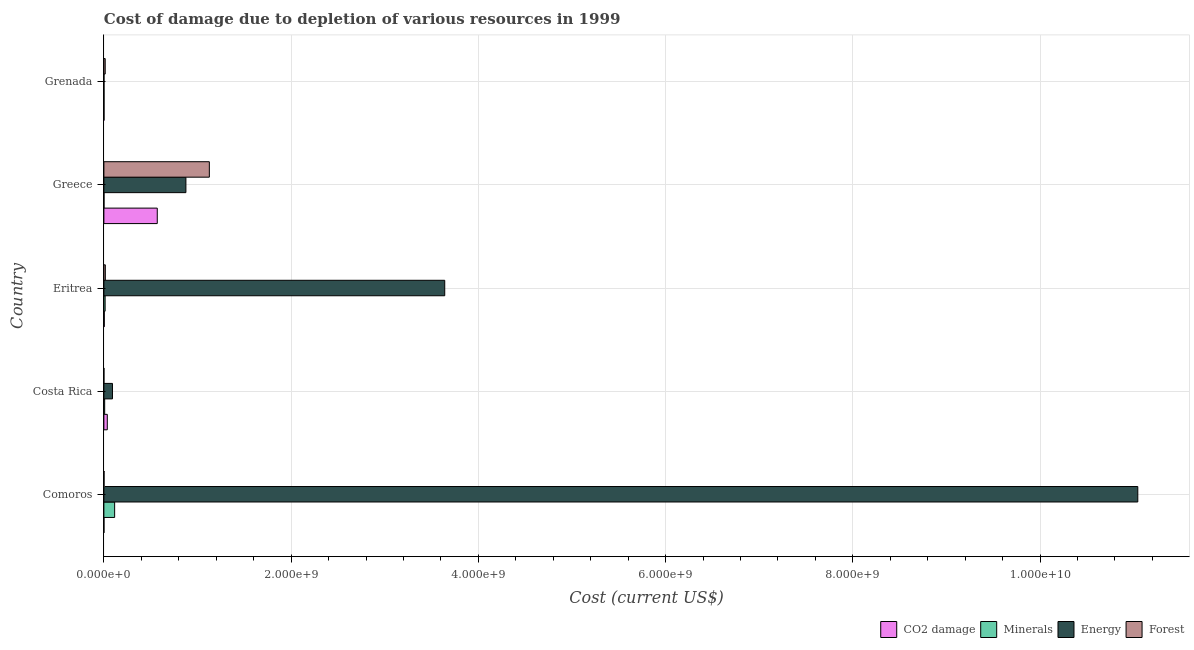How many groups of bars are there?
Give a very brief answer. 5. Are the number of bars per tick equal to the number of legend labels?
Provide a succinct answer. Yes. How many bars are there on the 1st tick from the top?
Make the answer very short. 4. How many bars are there on the 5th tick from the bottom?
Offer a very short reply. 4. What is the label of the 2nd group of bars from the top?
Make the answer very short. Greece. What is the cost of damage due to depletion of energy in Eritrea?
Your response must be concise. 3.64e+09. Across all countries, what is the maximum cost of damage due to depletion of coal?
Your answer should be very brief. 5.70e+08. Across all countries, what is the minimum cost of damage due to depletion of minerals?
Offer a terse response. 1.05e+06. In which country was the cost of damage due to depletion of minerals maximum?
Give a very brief answer. Comoros. What is the total cost of damage due to depletion of energy in the graph?
Your answer should be compact. 1.57e+1. What is the difference between the cost of damage due to depletion of minerals in Comoros and that in Eritrea?
Offer a terse response. 1.02e+08. What is the difference between the cost of damage due to depletion of coal in Eritrea and the cost of damage due to depletion of forests in Greece?
Keep it short and to the point. -1.12e+09. What is the average cost of damage due to depletion of energy per country?
Offer a very short reply. 3.13e+09. What is the difference between the cost of damage due to depletion of energy and cost of damage due to depletion of minerals in Eritrea?
Give a very brief answer. 3.63e+09. What is the ratio of the cost of damage due to depletion of forests in Comoros to that in Grenada?
Ensure brevity in your answer.  0.11. Is the cost of damage due to depletion of energy in Costa Rica less than that in Grenada?
Make the answer very short. No. What is the difference between the highest and the second highest cost of damage due to depletion of forests?
Provide a short and direct response. 1.11e+09. What is the difference between the highest and the lowest cost of damage due to depletion of minerals?
Your answer should be very brief. 1.14e+08. In how many countries, is the cost of damage due to depletion of forests greater than the average cost of damage due to depletion of forests taken over all countries?
Ensure brevity in your answer.  1. Is it the case that in every country, the sum of the cost of damage due to depletion of forests and cost of damage due to depletion of energy is greater than the sum of cost of damage due to depletion of coal and cost of damage due to depletion of minerals?
Make the answer very short. No. What does the 1st bar from the top in Grenada represents?
Your response must be concise. Forest. What does the 3rd bar from the bottom in Eritrea represents?
Keep it short and to the point. Energy. Is it the case that in every country, the sum of the cost of damage due to depletion of coal and cost of damage due to depletion of minerals is greater than the cost of damage due to depletion of energy?
Offer a terse response. No. Are the values on the major ticks of X-axis written in scientific E-notation?
Offer a very short reply. Yes. How many legend labels are there?
Offer a very short reply. 4. How are the legend labels stacked?
Offer a very short reply. Horizontal. What is the title of the graph?
Ensure brevity in your answer.  Cost of damage due to depletion of various resources in 1999 . What is the label or title of the X-axis?
Keep it short and to the point. Cost (current US$). What is the label or title of the Y-axis?
Your answer should be compact. Country. What is the Cost (current US$) of CO2 damage in Comoros?
Provide a short and direct response. 5.31e+05. What is the Cost (current US$) in Minerals in Comoros?
Make the answer very short. 1.15e+08. What is the Cost (current US$) of Energy in Comoros?
Your answer should be compact. 1.10e+1. What is the Cost (current US$) of Forest in Comoros?
Your answer should be very brief. 1.50e+06. What is the Cost (current US$) in CO2 damage in Costa Rica?
Give a very brief answer. 3.63e+07. What is the Cost (current US$) in Minerals in Costa Rica?
Your response must be concise. 8.26e+06. What is the Cost (current US$) of Energy in Costa Rica?
Give a very brief answer. 9.16e+07. What is the Cost (current US$) of Forest in Costa Rica?
Offer a terse response. 2.14e+05. What is the Cost (current US$) of CO2 damage in Eritrea?
Provide a short and direct response. 4.08e+06. What is the Cost (current US$) in Minerals in Eritrea?
Offer a terse response. 1.31e+07. What is the Cost (current US$) of Energy in Eritrea?
Provide a short and direct response. 3.64e+09. What is the Cost (current US$) of Forest in Eritrea?
Your answer should be very brief. 1.53e+07. What is the Cost (current US$) in CO2 damage in Greece?
Ensure brevity in your answer.  5.70e+08. What is the Cost (current US$) in Minerals in Greece?
Your answer should be very brief. 1.05e+06. What is the Cost (current US$) of Energy in Greece?
Ensure brevity in your answer.  8.76e+08. What is the Cost (current US$) in Forest in Greece?
Ensure brevity in your answer.  1.13e+09. What is the Cost (current US$) in CO2 damage in Grenada?
Make the answer very short. 1.28e+06. What is the Cost (current US$) of Minerals in Grenada?
Offer a terse response. 1.34e+06. What is the Cost (current US$) of Energy in Grenada?
Offer a terse response. 7.42e+05. What is the Cost (current US$) in Forest in Grenada?
Your answer should be compact. 1.40e+07. Across all countries, what is the maximum Cost (current US$) in CO2 damage?
Offer a very short reply. 5.70e+08. Across all countries, what is the maximum Cost (current US$) in Minerals?
Your response must be concise. 1.15e+08. Across all countries, what is the maximum Cost (current US$) in Energy?
Give a very brief answer. 1.10e+1. Across all countries, what is the maximum Cost (current US$) of Forest?
Your answer should be compact. 1.13e+09. Across all countries, what is the minimum Cost (current US$) of CO2 damage?
Your response must be concise. 5.31e+05. Across all countries, what is the minimum Cost (current US$) of Minerals?
Your response must be concise. 1.05e+06. Across all countries, what is the minimum Cost (current US$) in Energy?
Your answer should be very brief. 7.42e+05. Across all countries, what is the minimum Cost (current US$) of Forest?
Keep it short and to the point. 2.14e+05. What is the total Cost (current US$) of CO2 damage in the graph?
Your answer should be very brief. 6.12e+08. What is the total Cost (current US$) in Minerals in the graph?
Offer a very short reply. 1.39e+08. What is the total Cost (current US$) of Energy in the graph?
Give a very brief answer. 1.57e+1. What is the total Cost (current US$) of Forest in the graph?
Provide a succinct answer. 1.16e+09. What is the difference between the Cost (current US$) of CO2 damage in Comoros and that in Costa Rica?
Ensure brevity in your answer.  -3.58e+07. What is the difference between the Cost (current US$) in Minerals in Comoros and that in Costa Rica?
Give a very brief answer. 1.07e+08. What is the difference between the Cost (current US$) in Energy in Comoros and that in Costa Rica?
Your answer should be compact. 1.10e+1. What is the difference between the Cost (current US$) of Forest in Comoros and that in Costa Rica?
Offer a terse response. 1.29e+06. What is the difference between the Cost (current US$) in CO2 damage in Comoros and that in Eritrea?
Your answer should be very brief. -3.55e+06. What is the difference between the Cost (current US$) of Minerals in Comoros and that in Eritrea?
Your answer should be very brief. 1.02e+08. What is the difference between the Cost (current US$) in Energy in Comoros and that in Eritrea?
Offer a terse response. 7.40e+09. What is the difference between the Cost (current US$) of Forest in Comoros and that in Eritrea?
Your response must be concise. -1.38e+07. What is the difference between the Cost (current US$) in CO2 damage in Comoros and that in Greece?
Your response must be concise. -5.70e+08. What is the difference between the Cost (current US$) of Minerals in Comoros and that in Greece?
Your response must be concise. 1.14e+08. What is the difference between the Cost (current US$) in Energy in Comoros and that in Greece?
Provide a succinct answer. 1.02e+1. What is the difference between the Cost (current US$) of Forest in Comoros and that in Greece?
Provide a short and direct response. -1.12e+09. What is the difference between the Cost (current US$) in CO2 damage in Comoros and that in Grenada?
Offer a terse response. -7.48e+05. What is the difference between the Cost (current US$) of Minerals in Comoros and that in Grenada?
Offer a very short reply. 1.13e+08. What is the difference between the Cost (current US$) in Energy in Comoros and that in Grenada?
Give a very brief answer. 1.10e+1. What is the difference between the Cost (current US$) in Forest in Comoros and that in Grenada?
Offer a terse response. -1.25e+07. What is the difference between the Cost (current US$) of CO2 damage in Costa Rica and that in Eritrea?
Provide a short and direct response. 3.23e+07. What is the difference between the Cost (current US$) of Minerals in Costa Rica and that in Eritrea?
Give a very brief answer. -4.85e+06. What is the difference between the Cost (current US$) of Energy in Costa Rica and that in Eritrea?
Keep it short and to the point. -3.55e+09. What is the difference between the Cost (current US$) of Forest in Costa Rica and that in Eritrea?
Your answer should be compact. -1.51e+07. What is the difference between the Cost (current US$) in CO2 damage in Costa Rica and that in Greece?
Give a very brief answer. -5.34e+08. What is the difference between the Cost (current US$) in Minerals in Costa Rica and that in Greece?
Give a very brief answer. 7.21e+06. What is the difference between the Cost (current US$) in Energy in Costa Rica and that in Greece?
Your response must be concise. -7.84e+08. What is the difference between the Cost (current US$) in Forest in Costa Rica and that in Greece?
Your answer should be very brief. -1.13e+09. What is the difference between the Cost (current US$) in CO2 damage in Costa Rica and that in Grenada?
Provide a short and direct response. 3.51e+07. What is the difference between the Cost (current US$) of Minerals in Costa Rica and that in Grenada?
Make the answer very short. 6.92e+06. What is the difference between the Cost (current US$) in Energy in Costa Rica and that in Grenada?
Offer a very short reply. 9.09e+07. What is the difference between the Cost (current US$) in Forest in Costa Rica and that in Grenada?
Your response must be concise. -1.38e+07. What is the difference between the Cost (current US$) of CO2 damage in Eritrea and that in Greece?
Make the answer very short. -5.66e+08. What is the difference between the Cost (current US$) of Minerals in Eritrea and that in Greece?
Make the answer very short. 1.21e+07. What is the difference between the Cost (current US$) of Energy in Eritrea and that in Greece?
Give a very brief answer. 2.76e+09. What is the difference between the Cost (current US$) in Forest in Eritrea and that in Greece?
Make the answer very short. -1.11e+09. What is the difference between the Cost (current US$) in CO2 damage in Eritrea and that in Grenada?
Your answer should be very brief. 2.80e+06. What is the difference between the Cost (current US$) in Minerals in Eritrea and that in Grenada?
Give a very brief answer. 1.18e+07. What is the difference between the Cost (current US$) of Energy in Eritrea and that in Grenada?
Your answer should be very brief. 3.64e+09. What is the difference between the Cost (current US$) of Forest in Eritrea and that in Grenada?
Your response must be concise. 1.23e+06. What is the difference between the Cost (current US$) of CO2 damage in Greece and that in Grenada?
Your response must be concise. 5.69e+08. What is the difference between the Cost (current US$) of Minerals in Greece and that in Grenada?
Your answer should be compact. -2.85e+05. What is the difference between the Cost (current US$) of Energy in Greece and that in Grenada?
Your answer should be very brief. 8.75e+08. What is the difference between the Cost (current US$) in Forest in Greece and that in Grenada?
Provide a short and direct response. 1.11e+09. What is the difference between the Cost (current US$) in CO2 damage in Comoros and the Cost (current US$) in Minerals in Costa Rica?
Your answer should be very brief. -7.73e+06. What is the difference between the Cost (current US$) of CO2 damage in Comoros and the Cost (current US$) of Energy in Costa Rica?
Offer a very short reply. -9.11e+07. What is the difference between the Cost (current US$) in CO2 damage in Comoros and the Cost (current US$) in Forest in Costa Rica?
Offer a terse response. 3.17e+05. What is the difference between the Cost (current US$) of Minerals in Comoros and the Cost (current US$) of Energy in Costa Rica?
Provide a succinct answer. 2.32e+07. What is the difference between the Cost (current US$) in Minerals in Comoros and the Cost (current US$) in Forest in Costa Rica?
Provide a short and direct response. 1.15e+08. What is the difference between the Cost (current US$) in Energy in Comoros and the Cost (current US$) in Forest in Costa Rica?
Ensure brevity in your answer.  1.10e+1. What is the difference between the Cost (current US$) in CO2 damage in Comoros and the Cost (current US$) in Minerals in Eritrea?
Provide a short and direct response. -1.26e+07. What is the difference between the Cost (current US$) in CO2 damage in Comoros and the Cost (current US$) in Energy in Eritrea?
Ensure brevity in your answer.  -3.64e+09. What is the difference between the Cost (current US$) in CO2 damage in Comoros and the Cost (current US$) in Forest in Eritrea?
Give a very brief answer. -1.47e+07. What is the difference between the Cost (current US$) of Minerals in Comoros and the Cost (current US$) of Energy in Eritrea?
Make the answer very short. -3.53e+09. What is the difference between the Cost (current US$) in Minerals in Comoros and the Cost (current US$) in Forest in Eritrea?
Your response must be concise. 9.95e+07. What is the difference between the Cost (current US$) of Energy in Comoros and the Cost (current US$) of Forest in Eritrea?
Make the answer very short. 1.10e+1. What is the difference between the Cost (current US$) in CO2 damage in Comoros and the Cost (current US$) in Minerals in Greece?
Keep it short and to the point. -5.21e+05. What is the difference between the Cost (current US$) in CO2 damage in Comoros and the Cost (current US$) in Energy in Greece?
Give a very brief answer. -8.76e+08. What is the difference between the Cost (current US$) in CO2 damage in Comoros and the Cost (current US$) in Forest in Greece?
Keep it short and to the point. -1.13e+09. What is the difference between the Cost (current US$) of Minerals in Comoros and the Cost (current US$) of Energy in Greece?
Your answer should be compact. -7.61e+08. What is the difference between the Cost (current US$) of Minerals in Comoros and the Cost (current US$) of Forest in Greece?
Your response must be concise. -1.01e+09. What is the difference between the Cost (current US$) of Energy in Comoros and the Cost (current US$) of Forest in Greece?
Keep it short and to the point. 9.92e+09. What is the difference between the Cost (current US$) of CO2 damage in Comoros and the Cost (current US$) of Minerals in Grenada?
Offer a terse response. -8.06e+05. What is the difference between the Cost (current US$) in CO2 damage in Comoros and the Cost (current US$) in Energy in Grenada?
Ensure brevity in your answer.  -2.11e+05. What is the difference between the Cost (current US$) in CO2 damage in Comoros and the Cost (current US$) in Forest in Grenada?
Provide a short and direct response. -1.35e+07. What is the difference between the Cost (current US$) of Minerals in Comoros and the Cost (current US$) of Energy in Grenada?
Keep it short and to the point. 1.14e+08. What is the difference between the Cost (current US$) in Minerals in Comoros and the Cost (current US$) in Forest in Grenada?
Your answer should be compact. 1.01e+08. What is the difference between the Cost (current US$) of Energy in Comoros and the Cost (current US$) of Forest in Grenada?
Keep it short and to the point. 1.10e+1. What is the difference between the Cost (current US$) in CO2 damage in Costa Rica and the Cost (current US$) in Minerals in Eritrea?
Your answer should be compact. 2.32e+07. What is the difference between the Cost (current US$) of CO2 damage in Costa Rica and the Cost (current US$) of Energy in Eritrea?
Offer a terse response. -3.60e+09. What is the difference between the Cost (current US$) of CO2 damage in Costa Rica and the Cost (current US$) of Forest in Eritrea?
Ensure brevity in your answer.  2.11e+07. What is the difference between the Cost (current US$) in Minerals in Costa Rica and the Cost (current US$) in Energy in Eritrea?
Provide a succinct answer. -3.63e+09. What is the difference between the Cost (current US$) in Minerals in Costa Rica and the Cost (current US$) in Forest in Eritrea?
Your response must be concise. -7.01e+06. What is the difference between the Cost (current US$) in Energy in Costa Rica and the Cost (current US$) in Forest in Eritrea?
Offer a very short reply. 7.64e+07. What is the difference between the Cost (current US$) in CO2 damage in Costa Rica and the Cost (current US$) in Minerals in Greece?
Your answer should be compact. 3.53e+07. What is the difference between the Cost (current US$) of CO2 damage in Costa Rica and the Cost (current US$) of Energy in Greece?
Keep it short and to the point. -8.40e+08. What is the difference between the Cost (current US$) in CO2 damage in Costa Rica and the Cost (current US$) in Forest in Greece?
Offer a very short reply. -1.09e+09. What is the difference between the Cost (current US$) in Minerals in Costa Rica and the Cost (current US$) in Energy in Greece?
Keep it short and to the point. -8.68e+08. What is the difference between the Cost (current US$) in Minerals in Costa Rica and the Cost (current US$) in Forest in Greece?
Make the answer very short. -1.12e+09. What is the difference between the Cost (current US$) of Energy in Costa Rica and the Cost (current US$) of Forest in Greece?
Your answer should be very brief. -1.03e+09. What is the difference between the Cost (current US$) in CO2 damage in Costa Rica and the Cost (current US$) in Minerals in Grenada?
Keep it short and to the point. 3.50e+07. What is the difference between the Cost (current US$) in CO2 damage in Costa Rica and the Cost (current US$) in Energy in Grenada?
Keep it short and to the point. 3.56e+07. What is the difference between the Cost (current US$) of CO2 damage in Costa Rica and the Cost (current US$) of Forest in Grenada?
Keep it short and to the point. 2.23e+07. What is the difference between the Cost (current US$) of Minerals in Costa Rica and the Cost (current US$) of Energy in Grenada?
Give a very brief answer. 7.52e+06. What is the difference between the Cost (current US$) in Minerals in Costa Rica and the Cost (current US$) in Forest in Grenada?
Provide a short and direct response. -5.78e+06. What is the difference between the Cost (current US$) in Energy in Costa Rica and the Cost (current US$) in Forest in Grenada?
Make the answer very short. 7.76e+07. What is the difference between the Cost (current US$) of CO2 damage in Eritrea and the Cost (current US$) of Minerals in Greece?
Your answer should be very brief. 3.03e+06. What is the difference between the Cost (current US$) of CO2 damage in Eritrea and the Cost (current US$) of Energy in Greece?
Your answer should be compact. -8.72e+08. What is the difference between the Cost (current US$) in CO2 damage in Eritrea and the Cost (current US$) in Forest in Greece?
Ensure brevity in your answer.  -1.12e+09. What is the difference between the Cost (current US$) in Minerals in Eritrea and the Cost (current US$) in Energy in Greece?
Give a very brief answer. -8.63e+08. What is the difference between the Cost (current US$) of Minerals in Eritrea and the Cost (current US$) of Forest in Greece?
Give a very brief answer. -1.11e+09. What is the difference between the Cost (current US$) of Energy in Eritrea and the Cost (current US$) of Forest in Greece?
Offer a very short reply. 2.51e+09. What is the difference between the Cost (current US$) of CO2 damage in Eritrea and the Cost (current US$) of Minerals in Grenada?
Provide a succinct answer. 2.74e+06. What is the difference between the Cost (current US$) in CO2 damage in Eritrea and the Cost (current US$) in Energy in Grenada?
Your answer should be very brief. 3.34e+06. What is the difference between the Cost (current US$) in CO2 damage in Eritrea and the Cost (current US$) in Forest in Grenada?
Your response must be concise. -9.97e+06. What is the difference between the Cost (current US$) in Minerals in Eritrea and the Cost (current US$) in Energy in Grenada?
Offer a very short reply. 1.24e+07. What is the difference between the Cost (current US$) in Minerals in Eritrea and the Cost (current US$) in Forest in Grenada?
Provide a succinct answer. -9.33e+05. What is the difference between the Cost (current US$) of Energy in Eritrea and the Cost (current US$) of Forest in Grenada?
Your answer should be compact. 3.63e+09. What is the difference between the Cost (current US$) in CO2 damage in Greece and the Cost (current US$) in Minerals in Grenada?
Your answer should be compact. 5.69e+08. What is the difference between the Cost (current US$) in CO2 damage in Greece and the Cost (current US$) in Energy in Grenada?
Keep it short and to the point. 5.69e+08. What is the difference between the Cost (current US$) in CO2 damage in Greece and the Cost (current US$) in Forest in Grenada?
Your response must be concise. 5.56e+08. What is the difference between the Cost (current US$) of Minerals in Greece and the Cost (current US$) of Energy in Grenada?
Provide a succinct answer. 3.10e+05. What is the difference between the Cost (current US$) of Minerals in Greece and the Cost (current US$) of Forest in Grenada?
Provide a short and direct response. -1.30e+07. What is the difference between the Cost (current US$) in Energy in Greece and the Cost (current US$) in Forest in Grenada?
Make the answer very short. 8.62e+08. What is the average Cost (current US$) in CO2 damage per country?
Ensure brevity in your answer.  1.22e+08. What is the average Cost (current US$) of Minerals per country?
Ensure brevity in your answer.  2.77e+07. What is the average Cost (current US$) of Energy per country?
Offer a terse response. 3.13e+09. What is the average Cost (current US$) in Forest per country?
Offer a terse response. 2.31e+08. What is the difference between the Cost (current US$) in CO2 damage and Cost (current US$) in Minerals in Comoros?
Ensure brevity in your answer.  -1.14e+08. What is the difference between the Cost (current US$) in CO2 damage and Cost (current US$) in Energy in Comoros?
Provide a succinct answer. -1.10e+1. What is the difference between the Cost (current US$) in CO2 damage and Cost (current US$) in Forest in Comoros?
Offer a terse response. -9.70e+05. What is the difference between the Cost (current US$) of Minerals and Cost (current US$) of Energy in Comoros?
Your answer should be very brief. -1.09e+1. What is the difference between the Cost (current US$) of Minerals and Cost (current US$) of Forest in Comoros?
Ensure brevity in your answer.  1.13e+08. What is the difference between the Cost (current US$) in Energy and Cost (current US$) in Forest in Comoros?
Ensure brevity in your answer.  1.10e+1. What is the difference between the Cost (current US$) of CO2 damage and Cost (current US$) of Minerals in Costa Rica?
Offer a terse response. 2.81e+07. What is the difference between the Cost (current US$) in CO2 damage and Cost (current US$) in Energy in Costa Rica?
Provide a short and direct response. -5.53e+07. What is the difference between the Cost (current US$) of CO2 damage and Cost (current US$) of Forest in Costa Rica?
Your answer should be very brief. 3.61e+07. What is the difference between the Cost (current US$) in Minerals and Cost (current US$) in Energy in Costa Rica?
Offer a terse response. -8.34e+07. What is the difference between the Cost (current US$) of Minerals and Cost (current US$) of Forest in Costa Rica?
Provide a short and direct response. 8.05e+06. What is the difference between the Cost (current US$) in Energy and Cost (current US$) in Forest in Costa Rica?
Your response must be concise. 9.14e+07. What is the difference between the Cost (current US$) in CO2 damage and Cost (current US$) in Minerals in Eritrea?
Make the answer very short. -9.03e+06. What is the difference between the Cost (current US$) of CO2 damage and Cost (current US$) of Energy in Eritrea?
Ensure brevity in your answer.  -3.64e+09. What is the difference between the Cost (current US$) of CO2 damage and Cost (current US$) of Forest in Eritrea?
Give a very brief answer. -1.12e+07. What is the difference between the Cost (current US$) in Minerals and Cost (current US$) in Energy in Eritrea?
Your answer should be compact. -3.63e+09. What is the difference between the Cost (current US$) of Minerals and Cost (current US$) of Forest in Eritrea?
Your answer should be very brief. -2.16e+06. What is the difference between the Cost (current US$) in Energy and Cost (current US$) in Forest in Eritrea?
Offer a terse response. 3.63e+09. What is the difference between the Cost (current US$) of CO2 damage and Cost (current US$) of Minerals in Greece?
Your answer should be compact. 5.69e+08. What is the difference between the Cost (current US$) of CO2 damage and Cost (current US$) of Energy in Greece?
Offer a very short reply. -3.06e+08. What is the difference between the Cost (current US$) in CO2 damage and Cost (current US$) in Forest in Greece?
Provide a succinct answer. -5.56e+08. What is the difference between the Cost (current US$) in Minerals and Cost (current US$) in Energy in Greece?
Offer a very short reply. -8.75e+08. What is the difference between the Cost (current US$) in Minerals and Cost (current US$) in Forest in Greece?
Offer a terse response. -1.13e+09. What is the difference between the Cost (current US$) of Energy and Cost (current US$) of Forest in Greece?
Keep it short and to the point. -2.50e+08. What is the difference between the Cost (current US$) of CO2 damage and Cost (current US$) of Minerals in Grenada?
Keep it short and to the point. -5.78e+04. What is the difference between the Cost (current US$) in CO2 damage and Cost (current US$) in Energy in Grenada?
Keep it short and to the point. 5.37e+05. What is the difference between the Cost (current US$) in CO2 damage and Cost (current US$) in Forest in Grenada?
Your answer should be very brief. -1.28e+07. What is the difference between the Cost (current US$) in Minerals and Cost (current US$) in Energy in Grenada?
Make the answer very short. 5.95e+05. What is the difference between the Cost (current US$) in Minerals and Cost (current US$) in Forest in Grenada?
Ensure brevity in your answer.  -1.27e+07. What is the difference between the Cost (current US$) in Energy and Cost (current US$) in Forest in Grenada?
Provide a succinct answer. -1.33e+07. What is the ratio of the Cost (current US$) in CO2 damage in Comoros to that in Costa Rica?
Offer a terse response. 0.01. What is the ratio of the Cost (current US$) in Minerals in Comoros to that in Costa Rica?
Provide a succinct answer. 13.9. What is the ratio of the Cost (current US$) in Energy in Comoros to that in Costa Rica?
Make the answer very short. 120.52. What is the ratio of the Cost (current US$) of Forest in Comoros to that in Costa Rica?
Offer a very short reply. 7.01. What is the ratio of the Cost (current US$) in CO2 damage in Comoros to that in Eritrea?
Keep it short and to the point. 0.13. What is the ratio of the Cost (current US$) of Minerals in Comoros to that in Eritrea?
Ensure brevity in your answer.  8.75. What is the ratio of the Cost (current US$) of Energy in Comoros to that in Eritrea?
Ensure brevity in your answer.  3.03. What is the ratio of the Cost (current US$) of Forest in Comoros to that in Eritrea?
Offer a terse response. 0.1. What is the ratio of the Cost (current US$) in CO2 damage in Comoros to that in Greece?
Give a very brief answer. 0. What is the ratio of the Cost (current US$) in Minerals in Comoros to that in Greece?
Provide a succinct answer. 109.14. What is the ratio of the Cost (current US$) in Energy in Comoros to that in Greece?
Keep it short and to the point. 12.61. What is the ratio of the Cost (current US$) in Forest in Comoros to that in Greece?
Provide a short and direct response. 0. What is the ratio of the Cost (current US$) of CO2 damage in Comoros to that in Grenada?
Give a very brief answer. 0.42. What is the ratio of the Cost (current US$) of Minerals in Comoros to that in Grenada?
Your response must be concise. 85.86. What is the ratio of the Cost (current US$) of Energy in Comoros to that in Grenada?
Ensure brevity in your answer.  1.49e+04. What is the ratio of the Cost (current US$) in Forest in Comoros to that in Grenada?
Offer a terse response. 0.11. What is the ratio of the Cost (current US$) of CO2 damage in Costa Rica to that in Eritrea?
Provide a short and direct response. 8.91. What is the ratio of the Cost (current US$) in Minerals in Costa Rica to that in Eritrea?
Give a very brief answer. 0.63. What is the ratio of the Cost (current US$) in Energy in Costa Rica to that in Eritrea?
Provide a succinct answer. 0.03. What is the ratio of the Cost (current US$) of Forest in Costa Rica to that in Eritrea?
Offer a very short reply. 0.01. What is the ratio of the Cost (current US$) of CO2 damage in Costa Rica to that in Greece?
Keep it short and to the point. 0.06. What is the ratio of the Cost (current US$) in Minerals in Costa Rica to that in Greece?
Keep it short and to the point. 7.85. What is the ratio of the Cost (current US$) in Energy in Costa Rica to that in Greece?
Your response must be concise. 0.1. What is the ratio of the Cost (current US$) in Forest in Costa Rica to that in Greece?
Keep it short and to the point. 0. What is the ratio of the Cost (current US$) of CO2 damage in Costa Rica to that in Grenada?
Provide a succinct answer. 28.42. What is the ratio of the Cost (current US$) of Minerals in Costa Rica to that in Grenada?
Provide a short and direct response. 6.18. What is the ratio of the Cost (current US$) in Energy in Costa Rica to that in Grenada?
Make the answer very short. 123.46. What is the ratio of the Cost (current US$) of Forest in Costa Rica to that in Grenada?
Offer a very short reply. 0.02. What is the ratio of the Cost (current US$) of CO2 damage in Eritrea to that in Greece?
Give a very brief answer. 0.01. What is the ratio of the Cost (current US$) of Minerals in Eritrea to that in Greece?
Make the answer very short. 12.47. What is the ratio of the Cost (current US$) of Energy in Eritrea to that in Greece?
Your response must be concise. 4.16. What is the ratio of the Cost (current US$) in Forest in Eritrea to that in Greece?
Provide a short and direct response. 0.01. What is the ratio of the Cost (current US$) in CO2 damage in Eritrea to that in Grenada?
Provide a succinct answer. 3.19. What is the ratio of the Cost (current US$) of Minerals in Eritrea to that in Grenada?
Keep it short and to the point. 9.81. What is the ratio of the Cost (current US$) of Energy in Eritrea to that in Grenada?
Offer a very short reply. 4905.46. What is the ratio of the Cost (current US$) of Forest in Eritrea to that in Grenada?
Your answer should be very brief. 1.09. What is the ratio of the Cost (current US$) of CO2 damage in Greece to that in Grenada?
Your answer should be compact. 445.77. What is the ratio of the Cost (current US$) in Minerals in Greece to that in Grenada?
Provide a succinct answer. 0.79. What is the ratio of the Cost (current US$) in Energy in Greece to that in Grenada?
Your answer should be compact. 1180.37. What is the ratio of the Cost (current US$) of Forest in Greece to that in Grenada?
Keep it short and to the point. 80.19. What is the difference between the highest and the second highest Cost (current US$) of CO2 damage?
Provide a succinct answer. 5.34e+08. What is the difference between the highest and the second highest Cost (current US$) in Minerals?
Your answer should be compact. 1.02e+08. What is the difference between the highest and the second highest Cost (current US$) of Energy?
Ensure brevity in your answer.  7.40e+09. What is the difference between the highest and the second highest Cost (current US$) of Forest?
Provide a short and direct response. 1.11e+09. What is the difference between the highest and the lowest Cost (current US$) in CO2 damage?
Your answer should be very brief. 5.70e+08. What is the difference between the highest and the lowest Cost (current US$) of Minerals?
Give a very brief answer. 1.14e+08. What is the difference between the highest and the lowest Cost (current US$) of Energy?
Provide a short and direct response. 1.10e+1. What is the difference between the highest and the lowest Cost (current US$) in Forest?
Keep it short and to the point. 1.13e+09. 